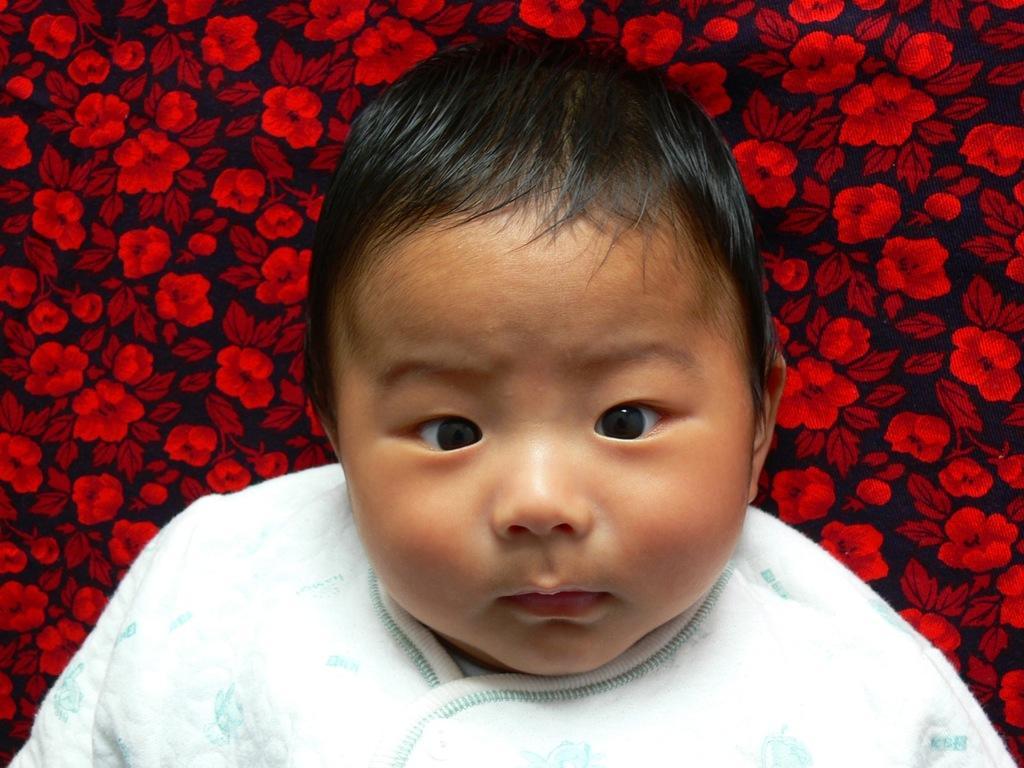Please provide a concise description of this image. In the image there is a baby. Behind the baby there is a floral cloth. 